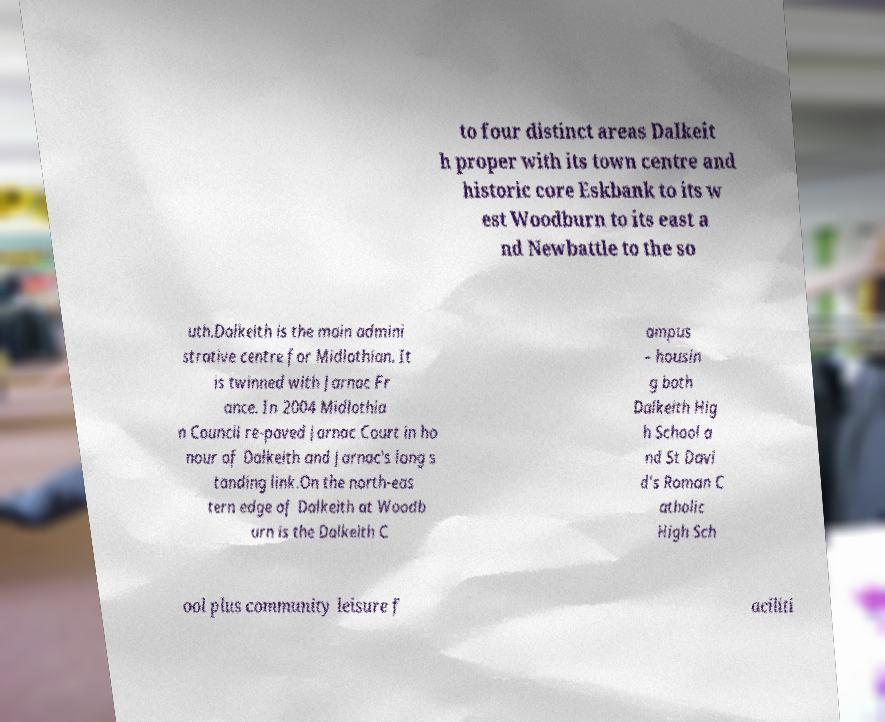Could you assist in decoding the text presented in this image and type it out clearly? to four distinct areas Dalkeit h proper with its town centre and historic core Eskbank to its w est Woodburn to its east a nd Newbattle to the so uth.Dalkeith is the main admini strative centre for Midlothian. It is twinned with Jarnac Fr ance. In 2004 Midlothia n Council re-paved Jarnac Court in ho nour of Dalkeith and Jarnac's long s tanding link.On the north-eas tern edge of Dalkeith at Woodb urn is the Dalkeith C ampus – housin g both Dalkeith Hig h School a nd St Davi d's Roman C atholic High Sch ool plus community leisure f aciliti 